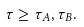<formula> <loc_0><loc_0><loc_500><loc_500>\tau \geq \tau _ { A } , \tau _ { B } .</formula> 